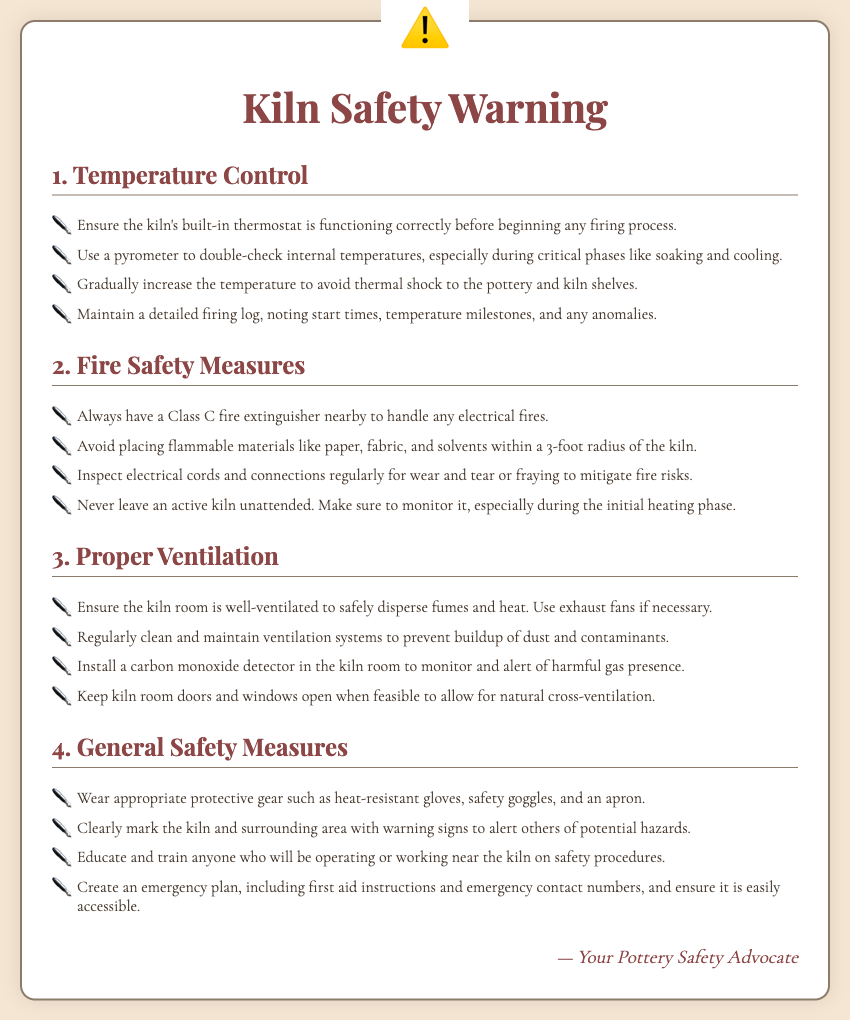What is the first topic mentioned in the warning label? The first topic in the warning label is listed as "Temperature Control."
Answer: Temperature Control How many fire safety measures are listed? There are four fire safety measures listed under the Fire Safety Measures section.
Answer: 4 What should you check to ensure proper temperature management? You should check the kiln's built-in thermostat to ensure it's functioning correctly.
Answer: Built-in thermostat What is a recommended action to take during critical temperature phases? It's recommended to use a pyrometer to double-check internal temperatures during critical phases.
Answer: Use a pyrometer What type of fire extinguisher should be nearby? A Class C fire extinguisher should be nearby to handle any electrical fires.
Answer: Class C What should be worn for protection when operating the kiln? Appropriate protective gear such as heat-resistant gloves, safety goggles, and an apron should be worn.
Answer: Heat-resistant gloves, safety goggles, apron What is one preventive maintenance action related to ventilation systems? Regularly clean and maintain ventilation systems to prevent buildup of dust and contaminants.
Answer: Clean and maintain What is crucial to document during the firing process? It's crucial to maintain a detailed firing log noting start times, temperature milestones, and anomalies.
Answer: Detailed firing log What should be installed in the kiln room to monitor gas levels? A carbon monoxide detector should be installed to monitor and alert of harmful gas presence.
Answer: Carbon monoxide detector 